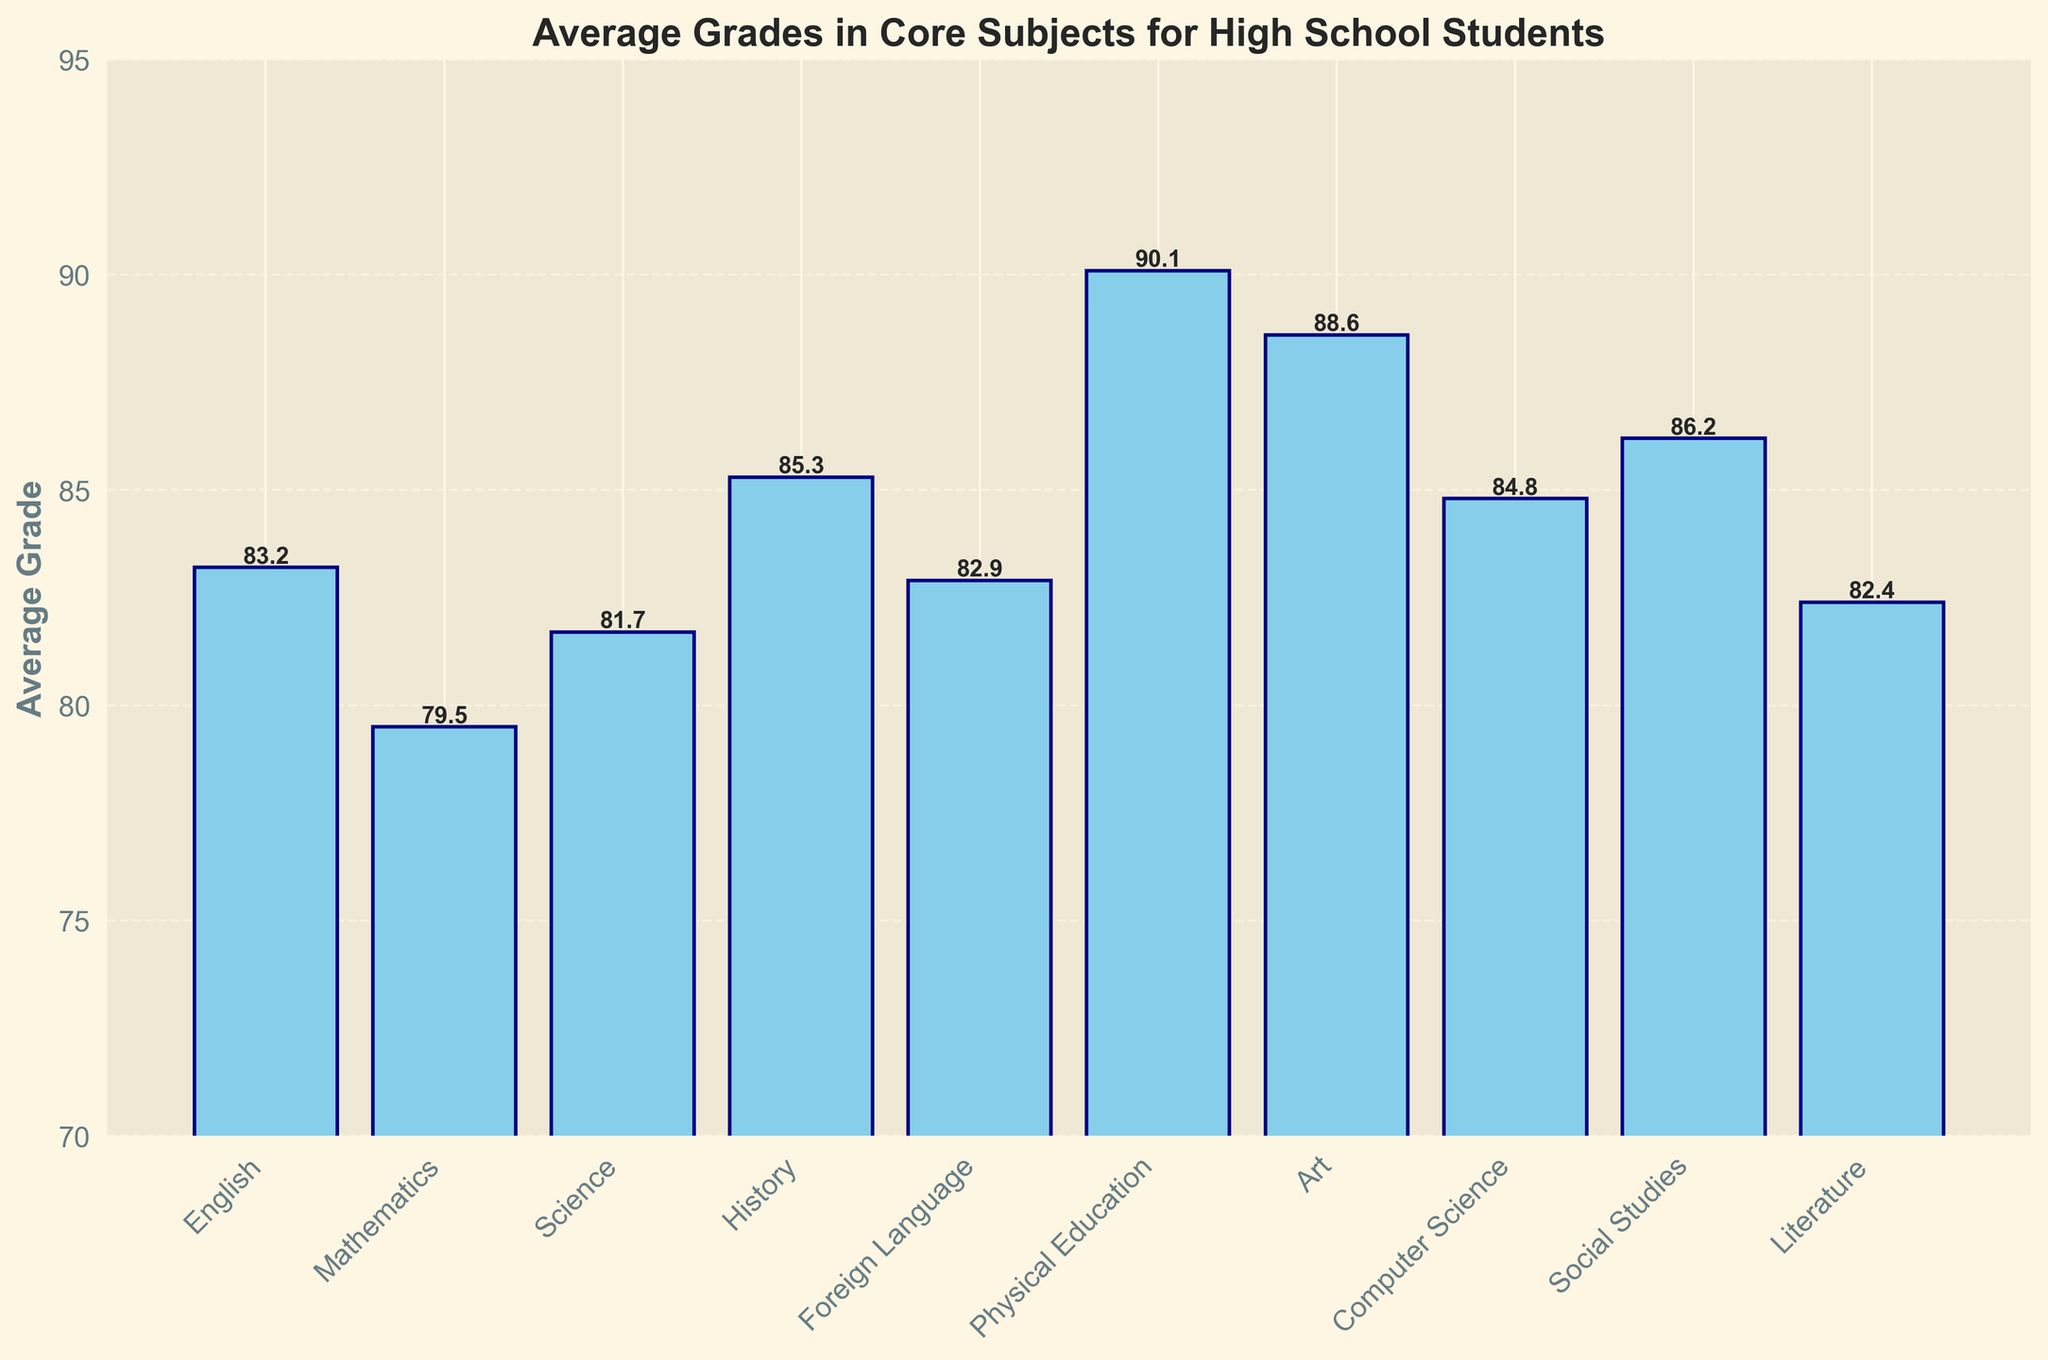Which subject has the highest average grade? From the chart, the subject with the highest bar represents the highest average grade. Physical Education has the highest bar.
Answer: Physical Education Which subject has the lowest average grade? From the chart, the subject with the shortest bar represents the lowest average grade. Mathematics has the shortest bar.
Answer: Mathematics What is the difference between the average grades of History and Mathematics? From the chart, the average grade for History is 85.3 and for Mathematics is 79.5. The difference is calculated as 85.3 - 79.5.
Answer: 5.8 Are there more subjects with an average grade above 85 than below 85? Count the number of subjects with bars above the 85-mark and those below it. Subjects above 85: History, Physical Education, Art, Computer Science, Social Studies. Subjects below 85: English, Mathematics, Science, Foreign Language, Literature. Both groups have the same count.
Answer: No What is the combined average grade of Science, Literature, and Social Studies? From the chart, the average grades are 81.7 (Science), 82.4 (Literature), and 86.2 (Social Studies). The sum is calculated as (81.7 + 82.4 + 86.2), then divided by 3 to get the average.
Answer: 83.43 Is the average grade in Computer Science higher than in Literature? From the chart, compare the heights of the bars for Computer Science (84.8) and Literature (82.4). Computer Science has a higher average grade.
Answer: Yes Which subjects have average grades between 80 and 85? Identify the bars which fall between the 80 and 85 marks. Subjects with these average grades are Science, Literature, Foreign Language, English, Computer Science.
Answer: Science, Literature, Foreign Language, English, Computer Science What is the average grade for all the subjects combined? Sum the average grades from all subjects: (83.2 + 79.5 + 81.7 + 85.3 + 82.9 + 90.1 + 88.6 + 84.8 + 86.2 + 82.4) and divide by the number of subjects (10).
Answer: 84.47 How much higher is the average grade in Physical Education compared to that in Art? From the chart, the average grade for Physical Education is 90.1 and for Art is 88.6. The difference is calculated as 90.1 - 88.6.
Answer: 1.5 Is Social Studies' average grade closer to Literature's or Mathematics'? Compare the differences: Social Studies (86.2) minus Literature (82.4) is 3.8, and Social Studies (86.2) minus Mathematics (79.5) is 6.7. Social Studies is closer to Literature.
Answer: Literature 